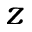<formula> <loc_0><loc_0><loc_500><loc_500>z</formula> 